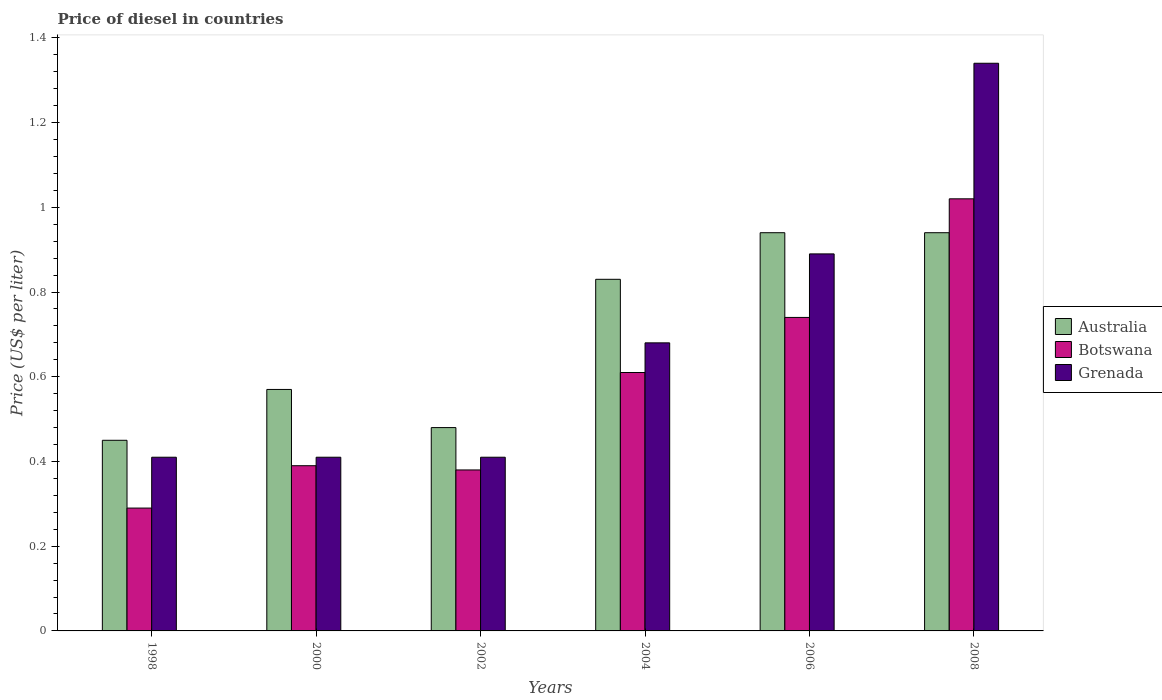How many different coloured bars are there?
Offer a terse response. 3. How many groups of bars are there?
Provide a succinct answer. 6. Are the number of bars per tick equal to the number of legend labels?
Your answer should be compact. Yes. How many bars are there on the 6th tick from the left?
Provide a succinct answer. 3. What is the label of the 1st group of bars from the left?
Keep it short and to the point. 1998. What is the price of diesel in Grenada in 2006?
Your response must be concise. 0.89. Across all years, what is the maximum price of diesel in Grenada?
Offer a terse response. 1.34. Across all years, what is the minimum price of diesel in Grenada?
Your answer should be very brief. 0.41. In which year was the price of diesel in Australia maximum?
Give a very brief answer. 2006. In which year was the price of diesel in Australia minimum?
Your answer should be compact. 1998. What is the total price of diesel in Australia in the graph?
Provide a succinct answer. 4.21. What is the difference between the price of diesel in Australia in 1998 and that in 2002?
Ensure brevity in your answer.  -0.03. What is the difference between the price of diesel in Grenada in 2000 and the price of diesel in Australia in 2006?
Keep it short and to the point. -0.53. What is the average price of diesel in Australia per year?
Your response must be concise. 0.7. In the year 2004, what is the difference between the price of diesel in Grenada and price of diesel in Australia?
Keep it short and to the point. -0.15. What is the ratio of the price of diesel in Botswana in 2002 to that in 2008?
Offer a terse response. 0.37. Is the price of diesel in Botswana in 1998 less than that in 2000?
Make the answer very short. Yes. Is the difference between the price of diesel in Grenada in 1998 and 2006 greater than the difference between the price of diesel in Australia in 1998 and 2006?
Make the answer very short. Yes. What is the difference between the highest and the lowest price of diesel in Grenada?
Make the answer very short. 0.93. What does the 2nd bar from the right in 2008 represents?
Your answer should be very brief. Botswana. Is it the case that in every year, the sum of the price of diesel in Botswana and price of diesel in Australia is greater than the price of diesel in Grenada?
Your answer should be very brief. Yes. How many bars are there?
Your response must be concise. 18. Are the values on the major ticks of Y-axis written in scientific E-notation?
Your response must be concise. No. Does the graph contain any zero values?
Your response must be concise. No. Does the graph contain grids?
Make the answer very short. No. What is the title of the graph?
Your answer should be compact. Price of diesel in countries. Does "High income: OECD" appear as one of the legend labels in the graph?
Offer a very short reply. No. What is the label or title of the X-axis?
Provide a succinct answer. Years. What is the label or title of the Y-axis?
Give a very brief answer. Price (US$ per liter). What is the Price (US$ per liter) of Australia in 1998?
Ensure brevity in your answer.  0.45. What is the Price (US$ per liter) in Botswana in 1998?
Offer a terse response. 0.29. What is the Price (US$ per liter) of Grenada in 1998?
Offer a terse response. 0.41. What is the Price (US$ per liter) in Australia in 2000?
Offer a very short reply. 0.57. What is the Price (US$ per liter) of Botswana in 2000?
Provide a succinct answer. 0.39. What is the Price (US$ per liter) of Grenada in 2000?
Provide a short and direct response. 0.41. What is the Price (US$ per liter) in Australia in 2002?
Keep it short and to the point. 0.48. What is the Price (US$ per liter) of Botswana in 2002?
Your response must be concise. 0.38. What is the Price (US$ per liter) of Grenada in 2002?
Make the answer very short. 0.41. What is the Price (US$ per liter) of Australia in 2004?
Keep it short and to the point. 0.83. What is the Price (US$ per liter) in Botswana in 2004?
Your response must be concise. 0.61. What is the Price (US$ per liter) in Grenada in 2004?
Make the answer very short. 0.68. What is the Price (US$ per liter) of Botswana in 2006?
Ensure brevity in your answer.  0.74. What is the Price (US$ per liter) in Grenada in 2006?
Offer a terse response. 0.89. What is the Price (US$ per liter) in Botswana in 2008?
Ensure brevity in your answer.  1.02. What is the Price (US$ per liter) of Grenada in 2008?
Provide a succinct answer. 1.34. Across all years, what is the maximum Price (US$ per liter) in Botswana?
Your answer should be compact. 1.02. Across all years, what is the maximum Price (US$ per liter) in Grenada?
Offer a very short reply. 1.34. Across all years, what is the minimum Price (US$ per liter) in Australia?
Your response must be concise. 0.45. Across all years, what is the minimum Price (US$ per liter) of Botswana?
Your answer should be compact. 0.29. Across all years, what is the minimum Price (US$ per liter) of Grenada?
Provide a short and direct response. 0.41. What is the total Price (US$ per liter) in Australia in the graph?
Provide a succinct answer. 4.21. What is the total Price (US$ per liter) of Botswana in the graph?
Make the answer very short. 3.43. What is the total Price (US$ per liter) of Grenada in the graph?
Your response must be concise. 4.14. What is the difference between the Price (US$ per liter) in Australia in 1998 and that in 2000?
Provide a short and direct response. -0.12. What is the difference between the Price (US$ per liter) in Botswana in 1998 and that in 2000?
Provide a succinct answer. -0.1. What is the difference between the Price (US$ per liter) of Grenada in 1998 and that in 2000?
Your answer should be compact. 0. What is the difference between the Price (US$ per liter) of Australia in 1998 and that in 2002?
Offer a very short reply. -0.03. What is the difference between the Price (US$ per liter) of Botswana in 1998 and that in 2002?
Ensure brevity in your answer.  -0.09. What is the difference between the Price (US$ per liter) in Australia in 1998 and that in 2004?
Offer a terse response. -0.38. What is the difference between the Price (US$ per liter) of Botswana in 1998 and that in 2004?
Ensure brevity in your answer.  -0.32. What is the difference between the Price (US$ per liter) in Grenada in 1998 and that in 2004?
Provide a succinct answer. -0.27. What is the difference between the Price (US$ per liter) in Australia in 1998 and that in 2006?
Give a very brief answer. -0.49. What is the difference between the Price (US$ per liter) of Botswana in 1998 and that in 2006?
Ensure brevity in your answer.  -0.45. What is the difference between the Price (US$ per liter) of Grenada in 1998 and that in 2006?
Your answer should be very brief. -0.48. What is the difference between the Price (US$ per liter) of Australia in 1998 and that in 2008?
Your answer should be compact. -0.49. What is the difference between the Price (US$ per liter) in Botswana in 1998 and that in 2008?
Offer a very short reply. -0.73. What is the difference between the Price (US$ per liter) of Grenada in 1998 and that in 2008?
Provide a short and direct response. -0.93. What is the difference between the Price (US$ per liter) in Australia in 2000 and that in 2002?
Your answer should be very brief. 0.09. What is the difference between the Price (US$ per liter) in Grenada in 2000 and that in 2002?
Your answer should be very brief. 0. What is the difference between the Price (US$ per liter) in Australia in 2000 and that in 2004?
Make the answer very short. -0.26. What is the difference between the Price (US$ per liter) of Botswana in 2000 and that in 2004?
Ensure brevity in your answer.  -0.22. What is the difference between the Price (US$ per liter) of Grenada in 2000 and that in 2004?
Ensure brevity in your answer.  -0.27. What is the difference between the Price (US$ per liter) of Australia in 2000 and that in 2006?
Make the answer very short. -0.37. What is the difference between the Price (US$ per liter) of Botswana in 2000 and that in 2006?
Your answer should be very brief. -0.35. What is the difference between the Price (US$ per liter) of Grenada in 2000 and that in 2006?
Provide a succinct answer. -0.48. What is the difference between the Price (US$ per liter) in Australia in 2000 and that in 2008?
Your response must be concise. -0.37. What is the difference between the Price (US$ per liter) in Botswana in 2000 and that in 2008?
Keep it short and to the point. -0.63. What is the difference between the Price (US$ per liter) of Grenada in 2000 and that in 2008?
Offer a very short reply. -0.93. What is the difference between the Price (US$ per liter) in Australia in 2002 and that in 2004?
Give a very brief answer. -0.35. What is the difference between the Price (US$ per liter) of Botswana in 2002 and that in 2004?
Ensure brevity in your answer.  -0.23. What is the difference between the Price (US$ per liter) in Grenada in 2002 and that in 2004?
Ensure brevity in your answer.  -0.27. What is the difference between the Price (US$ per liter) of Australia in 2002 and that in 2006?
Your response must be concise. -0.46. What is the difference between the Price (US$ per liter) of Botswana in 2002 and that in 2006?
Provide a short and direct response. -0.36. What is the difference between the Price (US$ per liter) in Grenada in 2002 and that in 2006?
Your answer should be very brief. -0.48. What is the difference between the Price (US$ per liter) in Australia in 2002 and that in 2008?
Keep it short and to the point. -0.46. What is the difference between the Price (US$ per liter) in Botswana in 2002 and that in 2008?
Offer a very short reply. -0.64. What is the difference between the Price (US$ per liter) in Grenada in 2002 and that in 2008?
Your response must be concise. -0.93. What is the difference between the Price (US$ per liter) of Australia in 2004 and that in 2006?
Keep it short and to the point. -0.11. What is the difference between the Price (US$ per liter) of Botswana in 2004 and that in 2006?
Keep it short and to the point. -0.13. What is the difference between the Price (US$ per liter) in Grenada in 2004 and that in 2006?
Offer a terse response. -0.21. What is the difference between the Price (US$ per liter) of Australia in 2004 and that in 2008?
Ensure brevity in your answer.  -0.11. What is the difference between the Price (US$ per liter) in Botswana in 2004 and that in 2008?
Offer a very short reply. -0.41. What is the difference between the Price (US$ per liter) in Grenada in 2004 and that in 2008?
Keep it short and to the point. -0.66. What is the difference between the Price (US$ per liter) in Botswana in 2006 and that in 2008?
Provide a succinct answer. -0.28. What is the difference between the Price (US$ per liter) in Grenada in 2006 and that in 2008?
Give a very brief answer. -0.45. What is the difference between the Price (US$ per liter) of Botswana in 1998 and the Price (US$ per liter) of Grenada in 2000?
Provide a succinct answer. -0.12. What is the difference between the Price (US$ per liter) in Australia in 1998 and the Price (US$ per liter) in Botswana in 2002?
Offer a very short reply. 0.07. What is the difference between the Price (US$ per liter) of Australia in 1998 and the Price (US$ per liter) of Grenada in 2002?
Your answer should be very brief. 0.04. What is the difference between the Price (US$ per liter) of Botswana in 1998 and the Price (US$ per liter) of Grenada in 2002?
Keep it short and to the point. -0.12. What is the difference between the Price (US$ per liter) of Australia in 1998 and the Price (US$ per liter) of Botswana in 2004?
Make the answer very short. -0.16. What is the difference between the Price (US$ per liter) of Australia in 1998 and the Price (US$ per liter) of Grenada in 2004?
Provide a succinct answer. -0.23. What is the difference between the Price (US$ per liter) of Botswana in 1998 and the Price (US$ per liter) of Grenada in 2004?
Offer a very short reply. -0.39. What is the difference between the Price (US$ per liter) in Australia in 1998 and the Price (US$ per liter) in Botswana in 2006?
Offer a very short reply. -0.29. What is the difference between the Price (US$ per liter) of Australia in 1998 and the Price (US$ per liter) of Grenada in 2006?
Offer a terse response. -0.44. What is the difference between the Price (US$ per liter) in Botswana in 1998 and the Price (US$ per liter) in Grenada in 2006?
Give a very brief answer. -0.6. What is the difference between the Price (US$ per liter) of Australia in 1998 and the Price (US$ per liter) of Botswana in 2008?
Provide a succinct answer. -0.57. What is the difference between the Price (US$ per liter) of Australia in 1998 and the Price (US$ per liter) of Grenada in 2008?
Offer a terse response. -0.89. What is the difference between the Price (US$ per liter) of Botswana in 1998 and the Price (US$ per liter) of Grenada in 2008?
Provide a short and direct response. -1.05. What is the difference between the Price (US$ per liter) of Australia in 2000 and the Price (US$ per liter) of Botswana in 2002?
Make the answer very short. 0.19. What is the difference between the Price (US$ per liter) of Australia in 2000 and the Price (US$ per liter) of Grenada in 2002?
Your answer should be very brief. 0.16. What is the difference between the Price (US$ per liter) of Botswana in 2000 and the Price (US$ per liter) of Grenada in 2002?
Your response must be concise. -0.02. What is the difference between the Price (US$ per liter) in Australia in 2000 and the Price (US$ per liter) in Botswana in 2004?
Provide a succinct answer. -0.04. What is the difference between the Price (US$ per liter) of Australia in 2000 and the Price (US$ per liter) of Grenada in 2004?
Keep it short and to the point. -0.11. What is the difference between the Price (US$ per liter) in Botswana in 2000 and the Price (US$ per liter) in Grenada in 2004?
Your answer should be compact. -0.29. What is the difference between the Price (US$ per liter) in Australia in 2000 and the Price (US$ per liter) in Botswana in 2006?
Ensure brevity in your answer.  -0.17. What is the difference between the Price (US$ per liter) of Australia in 2000 and the Price (US$ per liter) of Grenada in 2006?
Your answer should be compact. -0.32. What is the difference between the Price (US$ per liter) of Botswana in 2000 and the Price (US$ per liter) of Grenada in 2006?
Your answer should be very brief. -0.5. What is the difference between the Price (US$ per liter) of Australia in 2000 and the Price (US$ per liter) of Botswana in 2008?
Your answer should be compact. -0.45. What is the difference between the Price (US$ per liter) of Australia in 2000 and the Price (US$ per liter) of Grenada in 2008?
Give a very brief answer. -0.77. What is the difference between the Price (US$ per liter) of Botswana in 2000 and the Price (US$ per liter) of Grenada in 2008?
Provide a succinct answer. -0.95. What is the difference between the Price (US$ per liter) in Australia in 2002 and the Price (US$ per liter) in Botswana in 2004?
Give a very brief answer. -0.13. What is the difference between the Price (US$ per liter) of Australia in 2002 and the Price (US$ per liter) of Botswana in 2006?
Your answer should be very brief. -0.26. What is the difference between the Price (US$ per liter) in Australia in 2002 and the Price (US$ per liter) in Grenada in 2006?
Make the answer very short. -0.41. What is the difference between the Price (US$ per liter) in Botswana in 2002 and the Price (US$ per liter) in Grenada in 2006?
Offer a very short reply. -0.51. What is the difference between the Price (US$ per liter) in Australia in 2002 and the Price (US$ per liter) in Botswana in 2008?
Make the answer very short. -0.54. What is the difference between the Price (US$ per liter) of Australia in 2002 and the Price (US$ per liter) of Grenada in 2008?
Give a very brief answer. -0.86. What is the difference between the Price (US$ per liter) in Botswana in 2002 and the Price (US$ per liter) in Grenada in 2008?
Give a very brief answer. -0.96. What is the difference between the Price (US$ per liter) in Australia in 2004 and the Price (US$ per liter) in Botswana in 2006?
Your answer should be very brief. 0.09. What is the difference between the Price (US$ per liter) of Australia in 2004 and the Price (US$ per liter) of Grenada in 2006?
Your response must be concise. -0.06. What is the difference between the Price (US$ per liter) in Botswana in 2004 and the Price (US$ per liter) in Grenada in 2006?
Offer a terse response. -0.28. What is the difference between the Price (US$ per liter) in Australia in 2004 and the Price (US$ per liter) in Botswana in 2008?
Offer a terse response. -0.19. What is the difference between the Price (US$ per liter) of Australia in 2004 and the Price (US$ per liter) of Grenada in 2008?
Give a very brief answer. -0.51. What is the difference between the Price (US$ per liter) of Botswana in 2004 and the Price (US$ per liter) of Grenada in 2008?
Your answer should be very brief. -0.73. What is the difference between the Price (US$ per liter) of Australia in 2006 and the Price (US$ per liter) of Botswana in 2008?
Offer a terse response. -0.08. What is the difference between the Price (US$ per liter) of Botswana in 2006 and the Price (US$ per liter) of Grenada in 2008?
Make the answer very short. -0.6. What is the average Price (US$ per liter) of Australia per year?
Your answer should be very brief. 0.7. What is the average Price (US$ per liter) in Botswana per year?
Keep it short and to the point. 0.57. What is the average Price (US$ per liter) in Grenada per year?
Provide a succinct answer. 0.69. In the year 1998, what is the difference between the Price (US$ per liter) in Australia and Price (US$ per liter) in Botswana?
Make the answer very short. 0.16. In the year 1998, what is the difference between the Price (US$ per liter) in Botswana and Price (US$ per liter) in Grenada?
Keep it short and to the point. -0.12. In the year 2000, what is the difference between the Price (US$ per liter) in Australia and Price (US$ per liter) in Botswana?
Offer a terse response. 0.18. In the year 2000, what is the difference between the Price (US$ per liter) in Australia and Price (US$ per liter) in Grenada?
Your answer should be compact. 0.16. In the year 2000, what is the difference between the Price (US$ per liter) of Botswana and Price (US$ per liter) of Grenada?
Offer a very short reply. -0.02. In the year 2002, what is the difference between the Price (US$ per liter) of Australia and Price (US$ per liter) of Grenada?
Your answer should be very brief. 0.07. In the year 2002, what is the difference between the Price (US$ per liter) in Botswana and Price (US$ per liter) in Grenada?
Provide a short and direct response. -0.03. In the year 2004, what is the difference between the Price (US$ per liter) of Australia and Price (US$ per liter) of Botswana?
Provide a succinct answer. 0.22. In the year 2004, what is the difference between the Price (US$ per liter) in Botswana and Price (US$ per liter) in Grenada?
Provide a short and direct response. -0.07. In the year 2006, what is the difference between the Price (US$ per liter) of Australia and Price (US$ per liter) of Botswana?
Provide a short and direct response. 0.2. In the year 2008, what is the difference between the Price (US$ per liter) in Australia and Price (US$ per liter) in Botswana?
Your answer should be compact. -0.08. In the year 2008, what is the difference between the Price (US$ per liter) in Australia and Price (US$ per liter) in Grenada?
Provide a short and direct response. -0.4. In the year 2008, what is the difference between the Price (US$ per liter) of Botswana and Price (US$ per liter) of Grenada?
Ensure brevity in your answer.  -0.32. What is the ratio of the Price (US$ per liter) of Australia in 1998 to that in 2000?
Keep it short and to the point. 0.79. What is the ratio of the Price (US$ per liter) in Botswana in 1998 to that in 2000?
Your response must be concise. 0.74. What is the ratio of the Price (US$ per liter) of Australia in 1998 to that in 2002?
Your answer should be compact. 0.94. What is the ratio of the Price (US$ per liter) of Botswana in 1998 to that in 2002?
Ensure brevity in your answer.  0.76. What is the ratio of the Price (US$ per liter) of Grenada in 1998 to that in 2002?
Offer a very short reply. 1. What is the ratio of the Price (US$ per liter) of Australia in 1998 to that in 2004?
Give a very brief answer. 0.54. What is the ratio of the Price (US$ per liter) of Botswana in 1998 to that in 2004?
Give a very brief answer. 0.48. What is the ratio of the Price (US$ per liter) of Grenada in 1998 to that in 2004?
Your answer should be very brief. 0.6. What is the ratio of the Price (US$ per liter) in Australia in 1998 to that in 2006?
Your answer should be very brief. 0.48. What is the ratio of the Price (US$ per liter) in Botswana in 1998 to that in 2006?
Offer a very short reply. 0.39. What is the ratio of the Price (US$ per liter) of Grenada in 1998 to that in 2006?
Provide a succinct answer. 0.46. What is the ratio of the Price (US$ per liter) in Australia in 1998 to that in 2008?
Keep it short and to the point. 0.48. What is the ratio of the Price (US$ per liter) of Botswana in 1998 to that in 2008?
Offer a very short reply. 0.28. What is the ratio of the Price (US$ per liter) of Grenada in 1998 to that in 2008?
Make the answer very short. 0.31. What is the ratio of the Price (US$ per liter) of Australia in 2000 to that in 2002?
Give a very brief answer. 1.19. What is the ratio of the Price (US$ per liter) of Botswana in 2000 to that in 2002?
Your answer should be very brief. 1.03. What is the ratio of the Price (US$ per liter) of Grenada in 2000 to that in 2002?
Provide a succinct answer. 1. What is the ratio of the Price (US$ per liter) in Australia in 2000 to that in 2004?
Your answer should be very brief. 0.69. What is the ratio of the Price (US$ per liter) in Botswana in 2000 to that in 2004?
Make the answer very short. 0.64. What is the ratio of the Price (US$ per liter) of Grenada in 2000 to that in 2004?
Offer a terse response. 0.6. What is the ratio of the Price (US$ per liter) of Australia in 2000 to that in 2006?
Your answer should be compact. 0.61. What is the ratio of the Price (US$ per liter) in Botswana in 2000 to that in 2006?
Give a very brief answer. 0.53. What is the ratio of the Price (US$ per liter) in Grenada in 2000 to that in 2006?
Your answer should be compact. 0.46. What is the ratio of the Price (US$ per liter) in Australia in 2000 to that in 2008?
Make the answer very short. 0.61. What is the ratio of the Price (US$ per liter) in Botswana in 2000 to that in 2008?
Offer a terse response. 0.38. What is the ratio of the Price (US$ per liter) in Grenada in 2000 to that in 2008?
Ensure brevity in your answer.  0.31. What is the ratio of the Price (US$ per liter) of Australia in 2002 to that in 2004?
Provide a short and direct response. 0.58. What is the ratio of the Price (US$ per liter) in Botswana in 2002 to that in 2004?
Keep it short and to the point. 0.62. What is the ratio of the Price (US$ per liter) of Grenada in 2002 to that in 2004?
Provide a succinct answer. 0.6. What is the ratio of the Price (US$ per liter) of Australia in 2002 to that in 2006?
Provide a short and direct response. 0.51. What is the ratio of the Price (US$ per liter) in Botswana in 2002 to that in 2006?
Keep it short and to the point. 0.51. What is the ratio of the Price (US$ per liter) in Grenada in 2002 to that in 2006?
Provide a short and direct response. 0.46. What is the ratio of the Price (US$ per liter) of Australia in 2002 to that in 2008?
Your answer should be very brief. 0.51. What is the ratio of the Price (US$ per liter) in Botswana in 2002 to that in 2008?
Ensure brevity in your answer.  0.37. What is the ratio of the Price (US$ per liter) in Grenada in 2002 to that in 2008?
Your answer should be compact. 0.31. What is the ratio of the Price (US$ per liter) of Australia in 2004 to that in 2006?
Your response must be concise. 0.88. What is the ratio of the Price (US$ per liter) of Botswana in 2004 to that in 2006?
Provide a succinct answer. 0.82. What is the ratio of the Price (US$ per liter) in Grenada in 2004 to that in 2006?
Give a very brief answer. 0.76. What is the ratio of the Price (US$ per liter) in Australia in 2004 to that in 2008?
Offer a very short reply. 0.88. What is the ratio of the Price (US$ per liter) in Botswana in 2004 to that in 2008?
Your response must be concise. 0.6. What is the ratio of the Price (US$ per liter) in Grenada in 2004 to that in 2008?
Make the answer very short. 0.51. What is the ratio of the Price (US$ per liter) of Australia in 2006 to that in 2008?
Your answer should be compact. 1. What is the ratio of the Price (US$ per liter) in Botswana in 2006 to that in 2008?
Your answer should be compact. 0.73. What is the ratio of the Price (US$ per liter) in Grenada in 2006 to that in 2008?
Make the answer very short. 0.66. What is the difference between the highest and the second highest Price (US$ per liter) in Australia?
Your answer should be compact. 0. What is the difference between the highest and the second highest Price (US$ per liter) in Botswana?
Offer a terse response. 0.28. What is the difference between the highest and the second highest Price (US$ per liter) of Grenada?
Offer a terse response. 0.45. What is the difference between the highest and the lowest Price (US$ per liter) in Australia?
Provide a short and direct response. 0.49. What is the difference between the highest and the lowest Price (US$ per liter) in Botswana?
Provide a short and direct response. 0.73. 